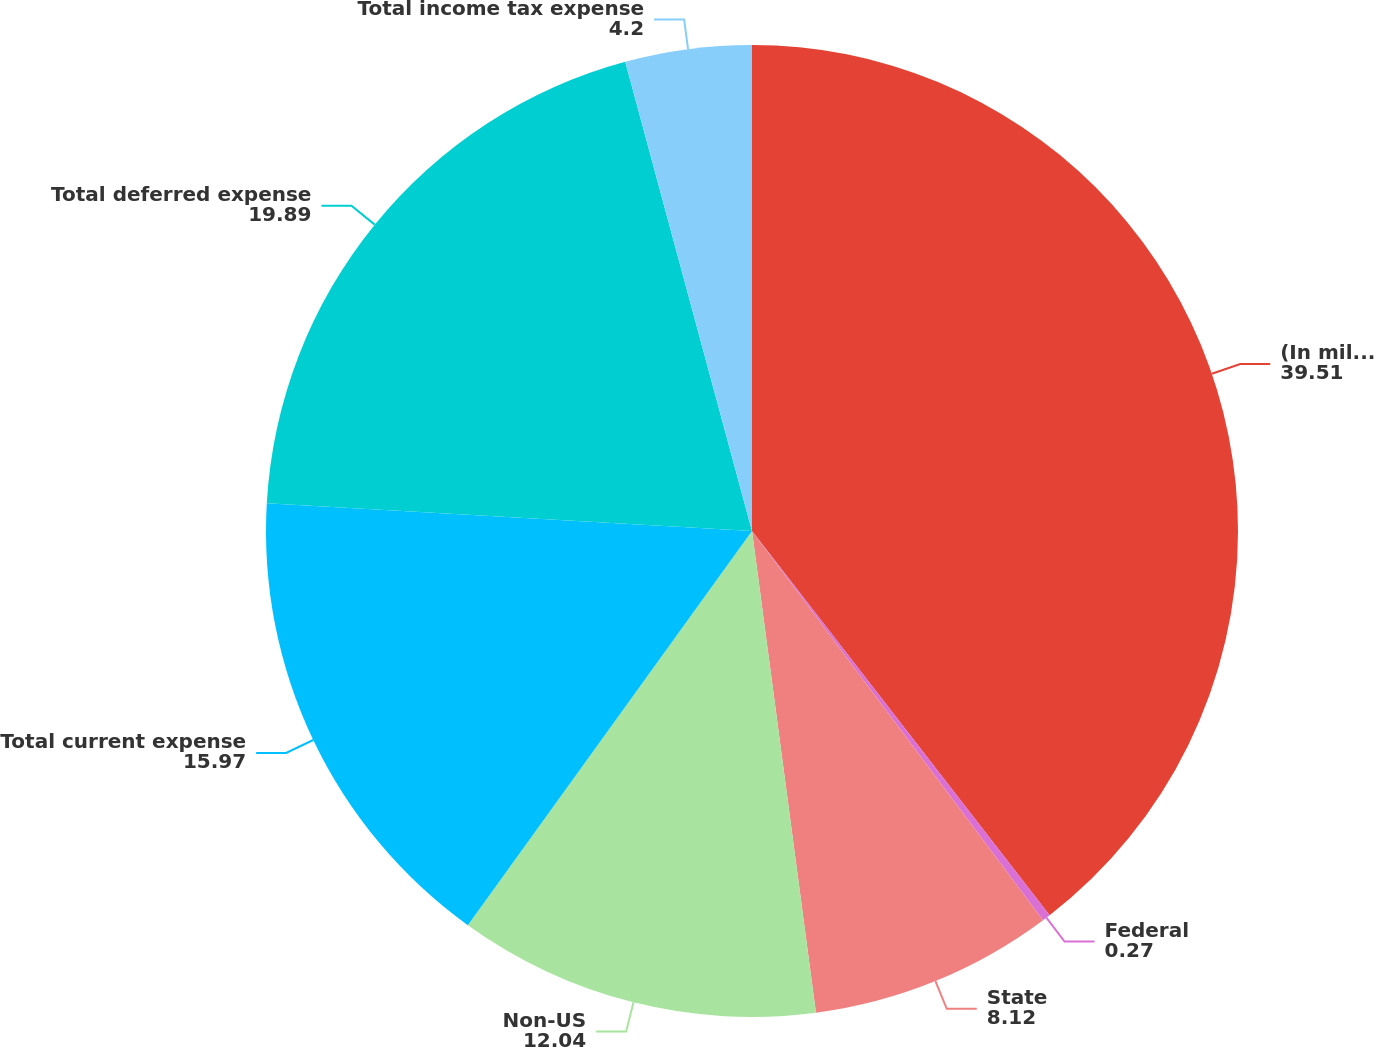<chart> <loc_0><loc_0><loc_500><loc_500><pie_chart><fcel>(In millions)<fcel>Federal<fcel>State<fcel>Non-US<fcel>Total current expense<fcel>Total deferred expense<fcel>Total income tax expense<nl><fcel>39.51%<fcel>0.27%<fcel>8.12%<fcel>12.04%<fcel>15.97%<fcel>19.89%<fcel>4.2%<nl></chart> 